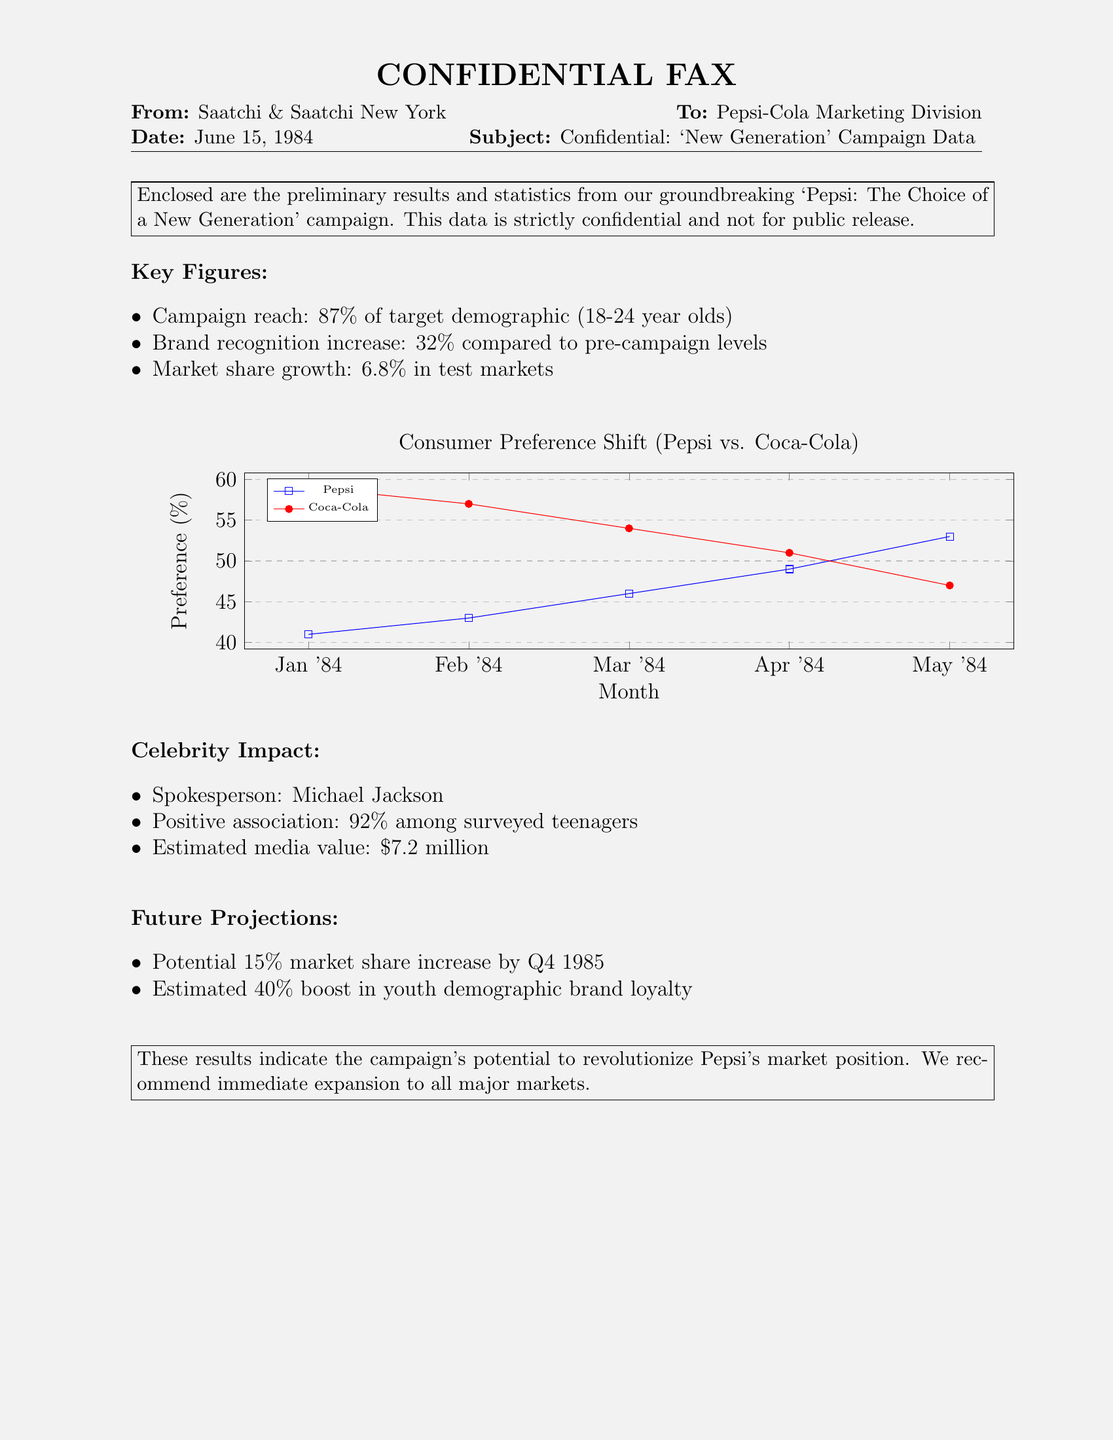What is the campaign reach? The campaign reach is the percentage of the target demographic that was reached, as stated in the document.
Answer: 87% Who is the spokesperson for the campaign? The document lists the spokesperson, highlighting their role in the campaign's success.
Answer: Michael Jackson What is the estimated media value? This value represents the financial impact of the celebrity association mentioned in the document.
Answer: $7.2 million What was the increase in brand recognition? The document specifies the percentage increase in brand recognition compared to pre-campaign levels.
Answer: 32% What was the market share growth in test markets? This statistic indicates the percentage growth of Pepsi's market share as a result of the campaign's efforts.
Answer: 6.8% Which brand had a higher initial preference percentage in January 1984? The data shows which brand had more consumer preference at the beginning of the campaign.
Answer: Coca-Cola What is the projected potential market share increase by Q4 1985? This projection outlines the anticipated growth in market share as a result of ongoing campaign efforts.
Answer: 15% What percentage of surveyed teenagers had a positive association with the spokesperson? The document indicates how well the spokesperson was received among teenagers.
Answer: 92% What is the primary target demographic for the campaign? This detail covers the main audience the campaign aimed to reach.
Answer: 18-24 year olds 